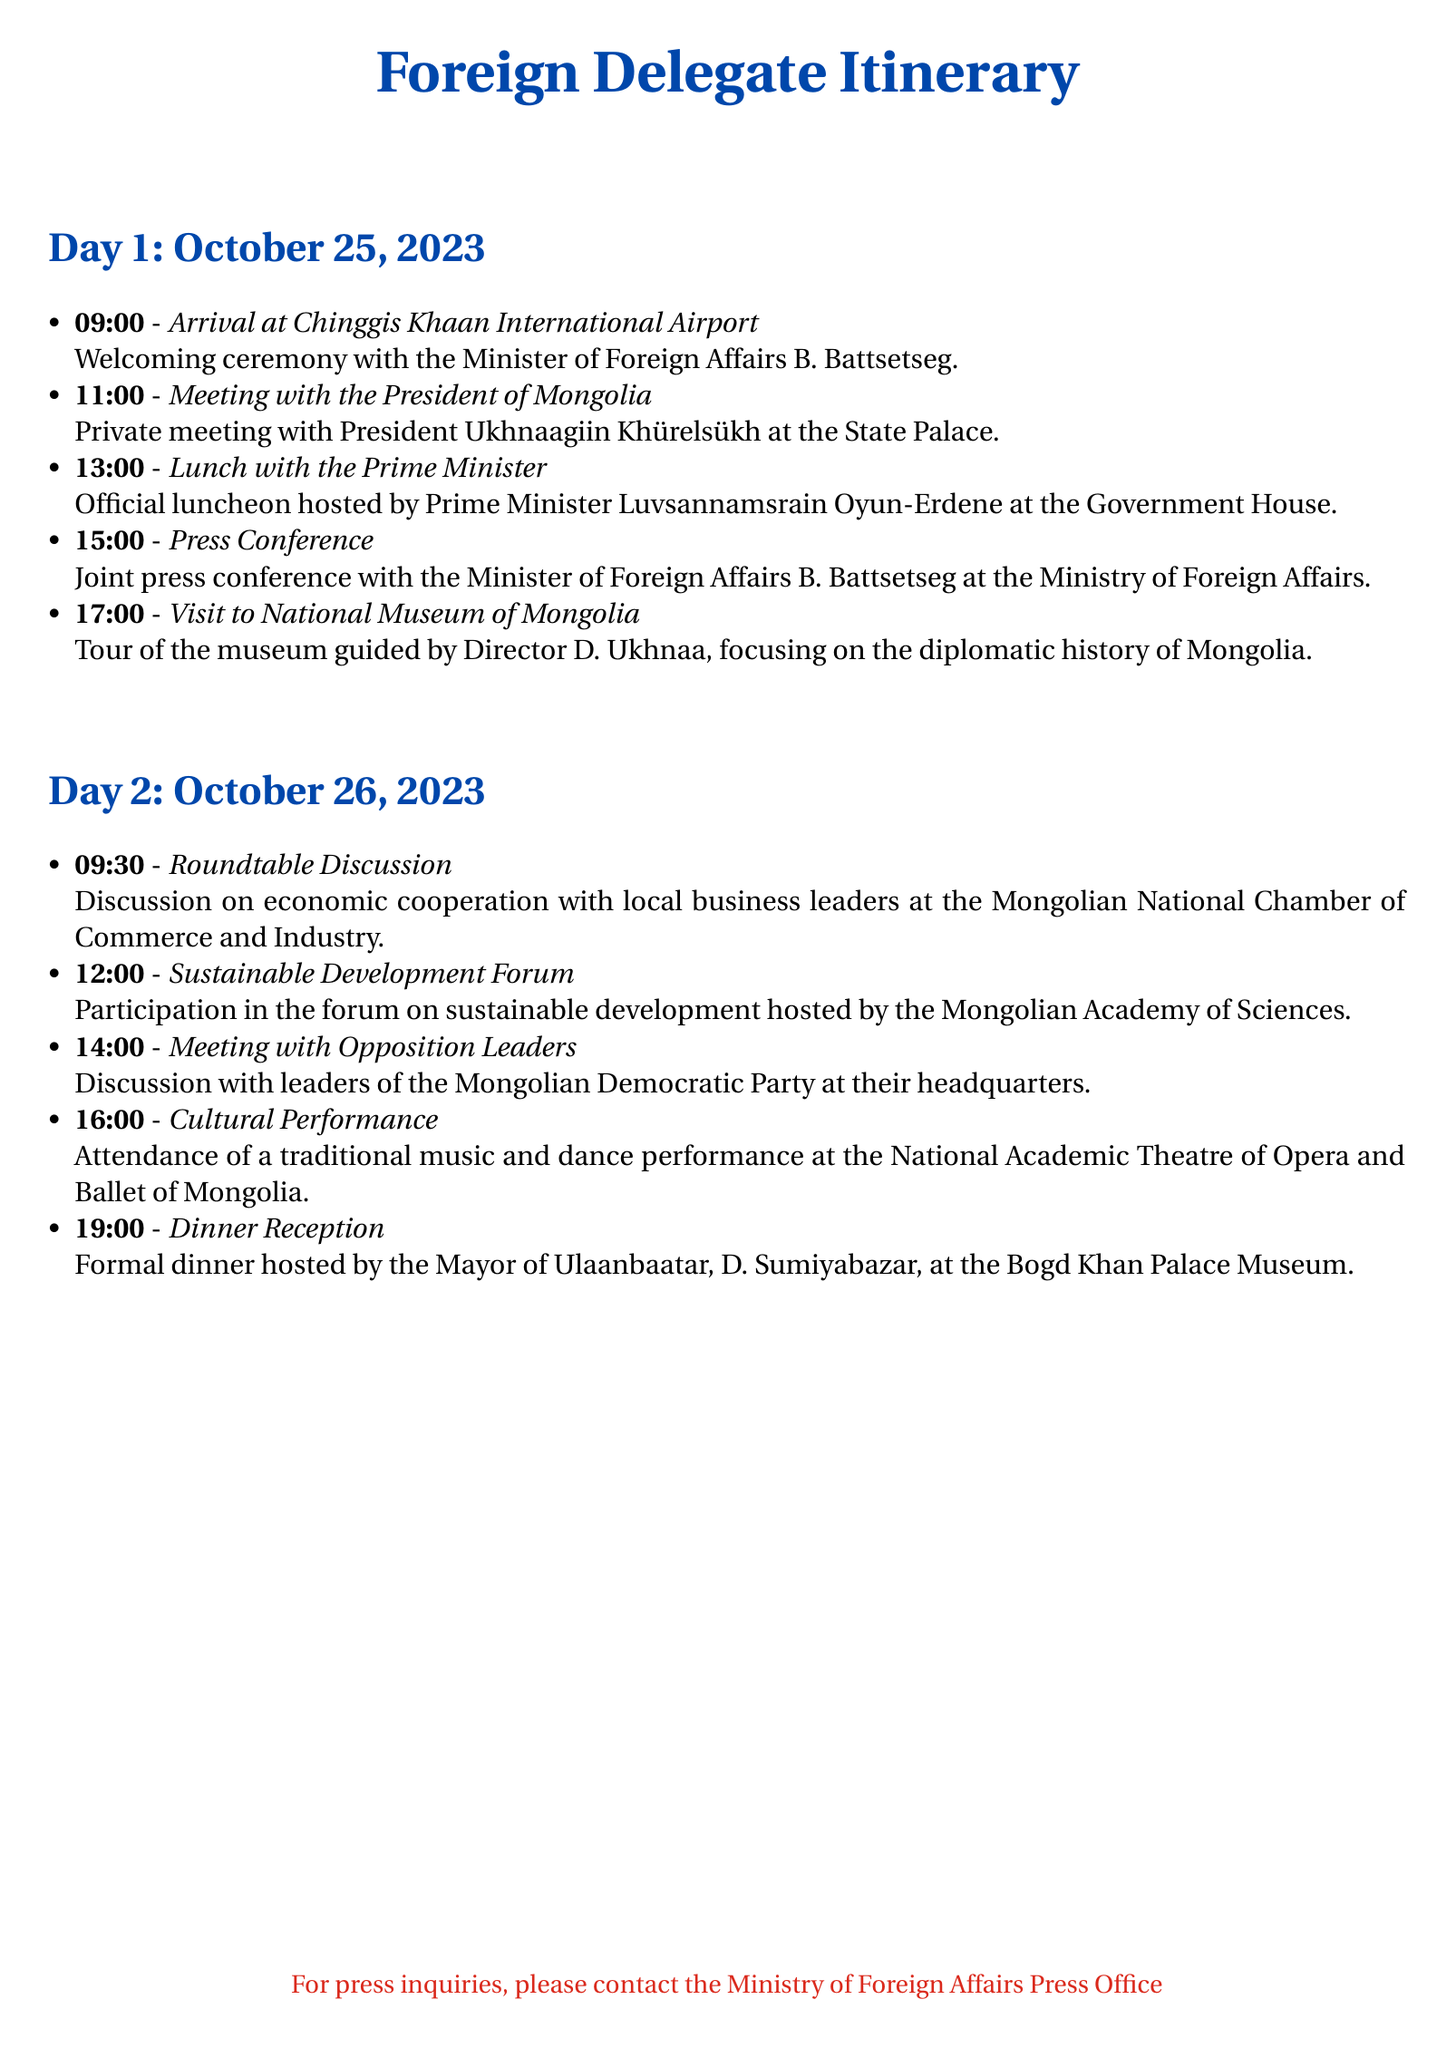what is the date of the arrival at Chinggis Khaan International Airport? The document states the arrival is scheduled for October 25, 2023.
Answer: October 25, 2023 who is hosting the official luncheon? The document specifies that the Prime Minister is hosting the luncheon on Day 1.
Answer: Prime Minister Luvsannamsrain Oyun-Erdene what time is the press conference scheduled? According to the itinerary, the press conference is set for 15:00 on Day 1.
Answer: 15:00 what was the focus of the roundtable discussion? The document indicates that the discussion centers on economic cooperation with local business leaders.
Answer: Economic cooperation who guided the visit to the National Museum of Mongolia? The itinerary mentions that the director of the museum will guide the visit.
Answer: Director D. Ukhnaa how many events are scheduled for Day 2? The document lists five events on Day 2.
Answer: 5 what is the venue for the dinner reception? The document states that the dinner reception will be held at the Bogd Khan Palace Museum.
Answer: Bogd Khan Palace Museum what type of performance is scheduled on Day 2? According to the itinerary, a traditional music and dance performance is planned.
Answer: Traditional music and dance performance 